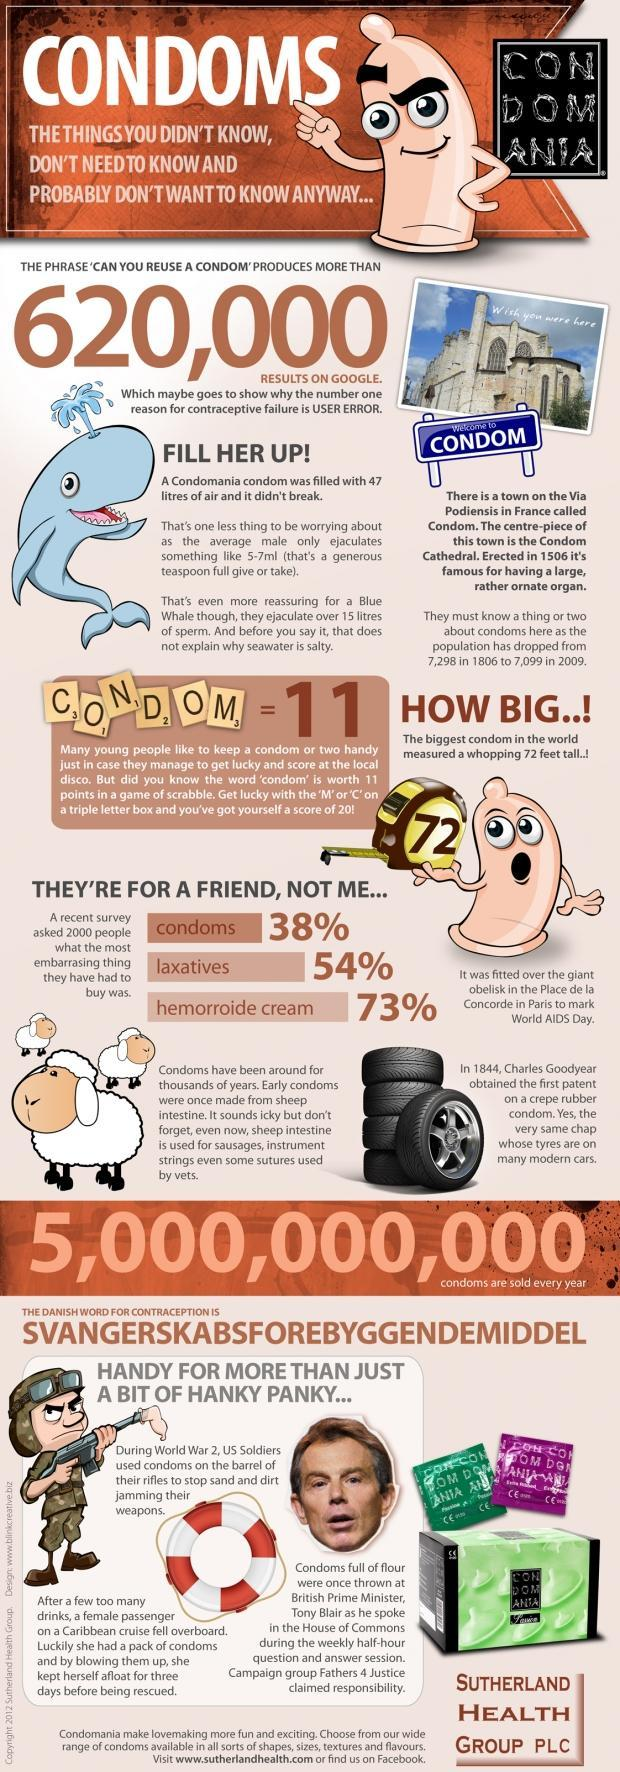What is the name of the famous person who was thrown with condoms?
Answer the question with a short phrase. Tony Blair 